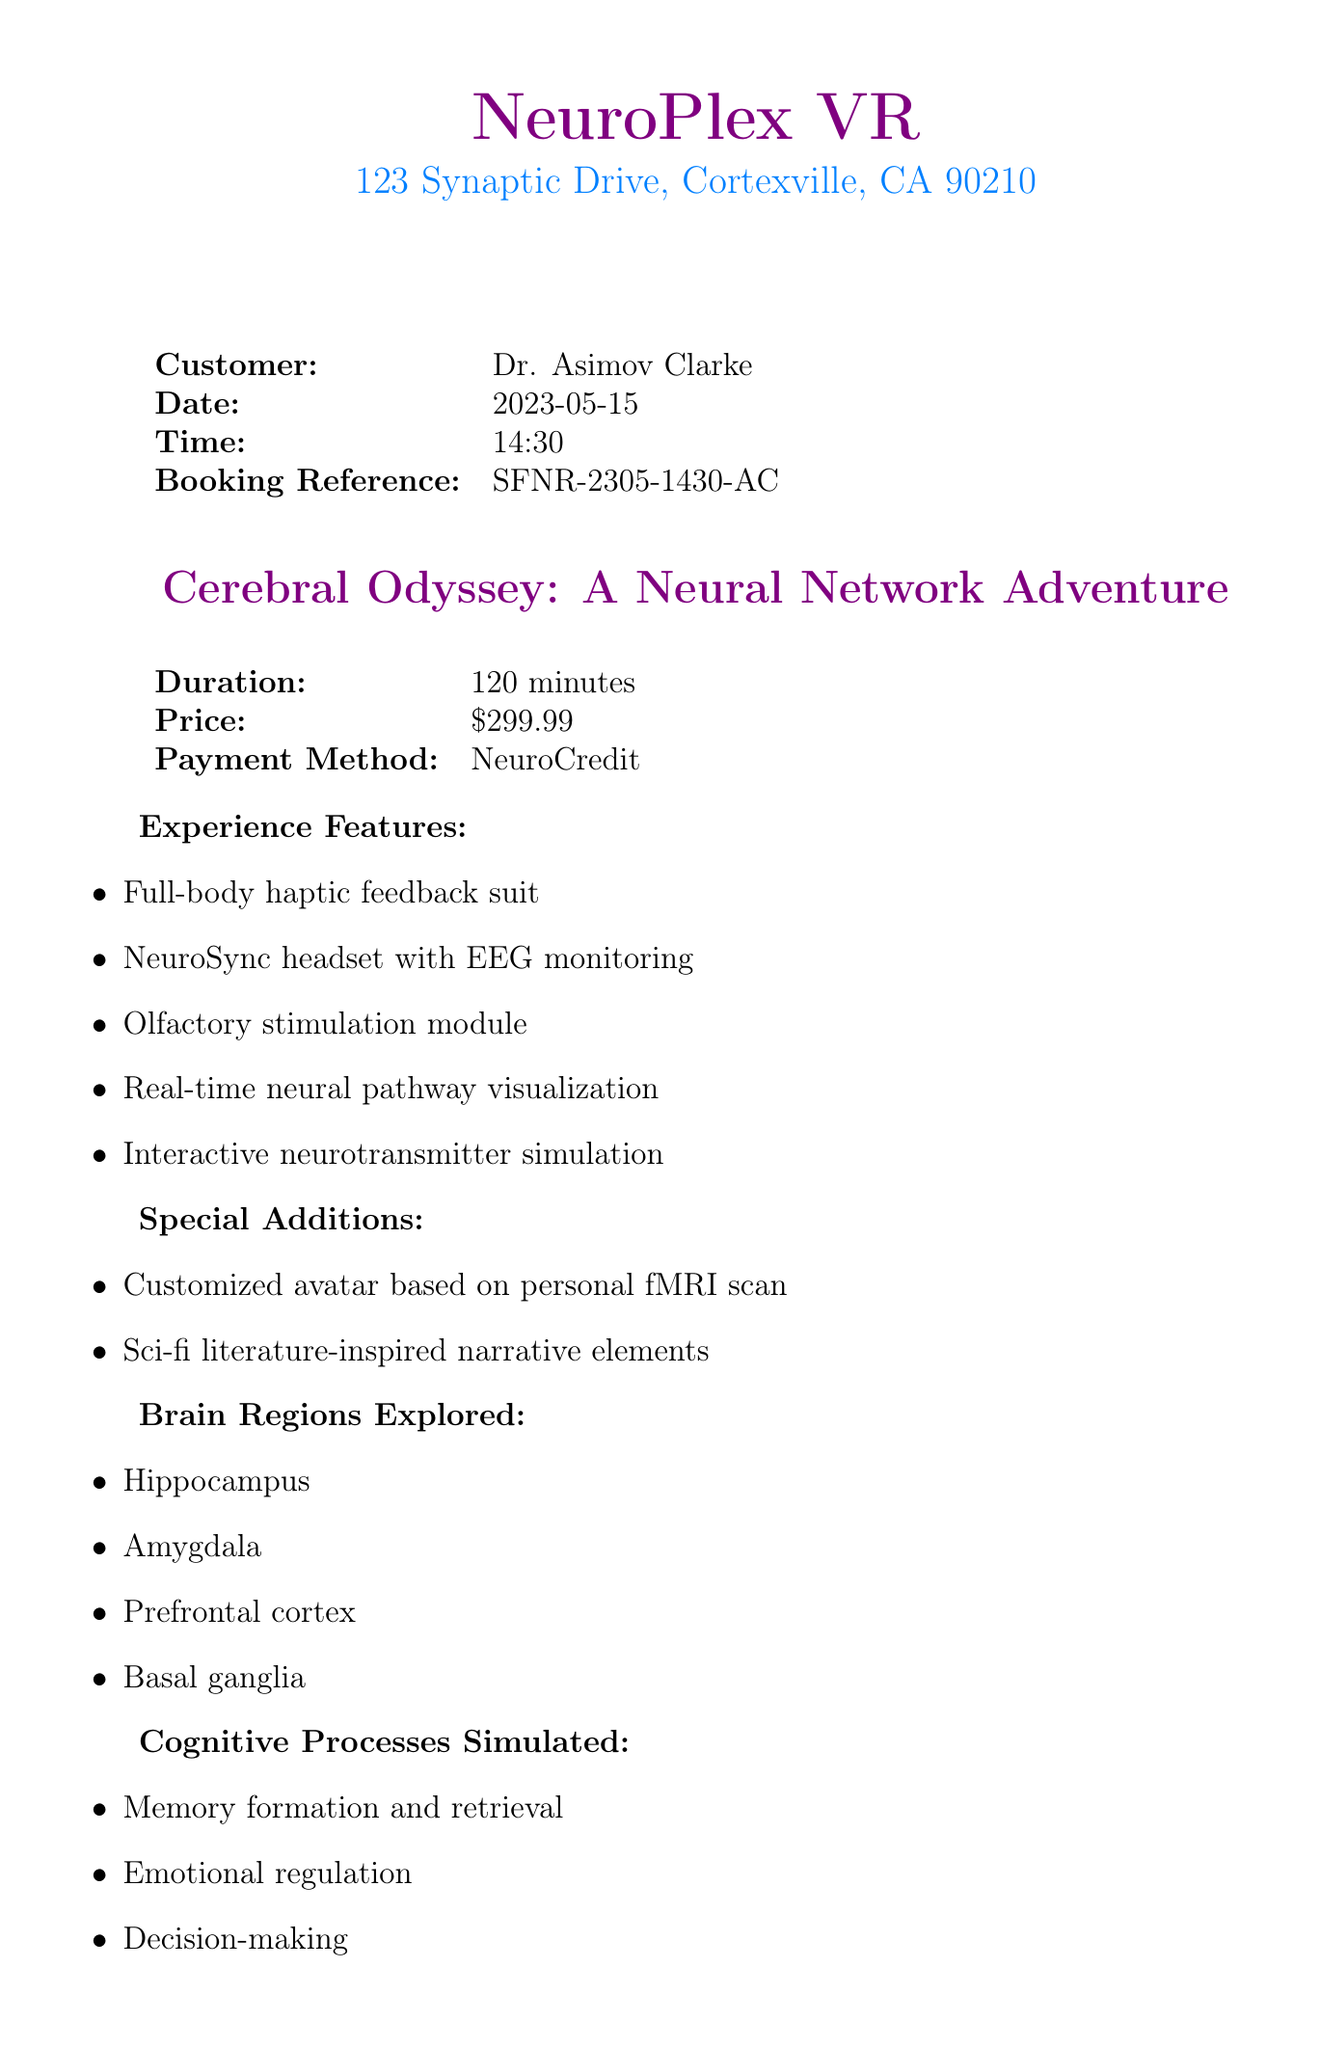What is the company name? The company name is the first piece of information listed in the document.
Answer: NeuroPlex VR What is the price of the experience? The price is clearly stated in a specific section of the document regarding pricing.
Answer: $299.99 What is the duration of the experience? The duration is mentioned alongside the experience's features and pricing.
Answer: 120 minutes Name one feature of the experience. Multiple features are listed, any one of which can be used to answer this question.
Answer: Full-body haptic feedback suit What region of the brain is explored in this experience? A specific list of brain regions explored is provided in the document.
Answer: Hippocampus How many cognitive processes are simulated? The number of cognitive processes is indicated by counting the items in the corresponding section.
Answer: Four What is the booking reference? The booking reference is listed clearly in the customer's details section.
Answer: SFNR-2305-1430-AC What is the payment method used? The payment method is noted in the pricing table of the document.
Answer: NeuroCredit What kind of analysis is provided post-experience? The type of analysis is specified in a dedicated section about post-experience.
Answer: 30-minute debrief with AI-powered neural activity interpretation 